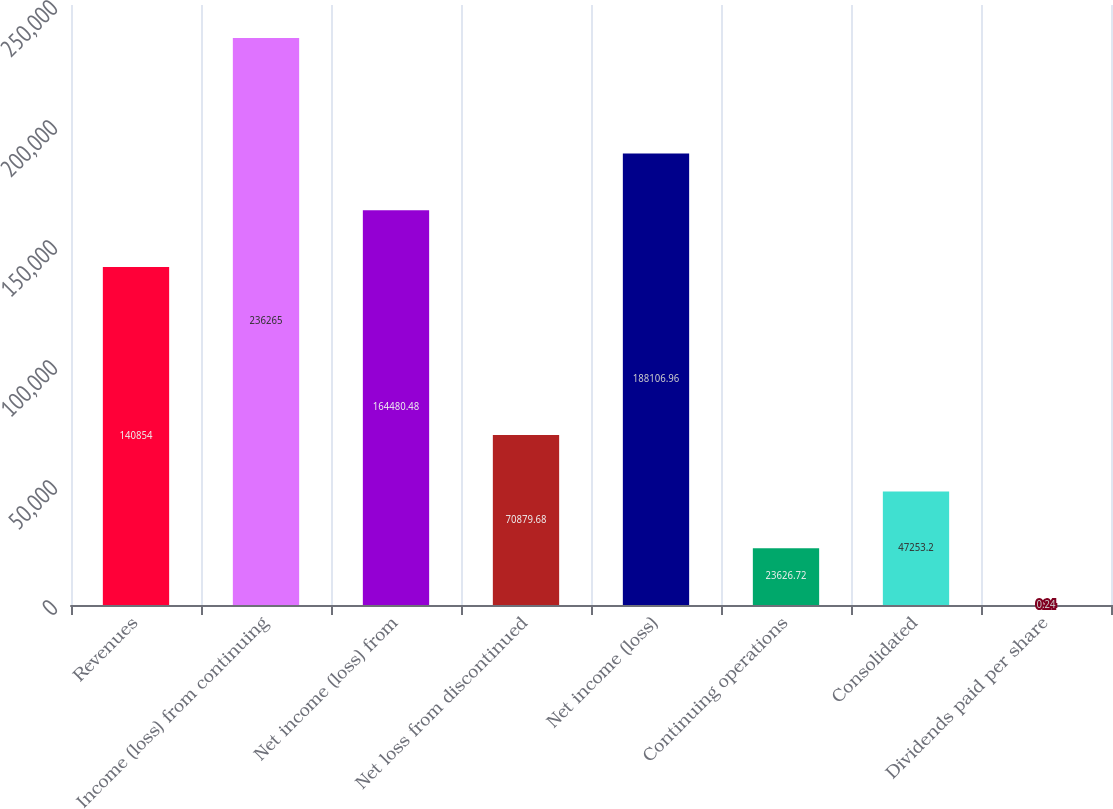Convert chart. <chart><loc_0><loc_0><loc_500><loc_500><bar_chart><fcel>Revenues<fcel>Income (loss) from continuing<fcel>Net income (loss) from<fcel>Net loss from discontinued<fcel>Net income (loss)<fcel>Continuing operations<fcel>Consolidated<fcel>Dividends paid per share<nl><fcel>140854<fcel>236265<fcel>164480<fcel>70879.7<fcel>188107<fcel>23626.7<fcel>47253.2<fcel>0.24<nl></chart> 